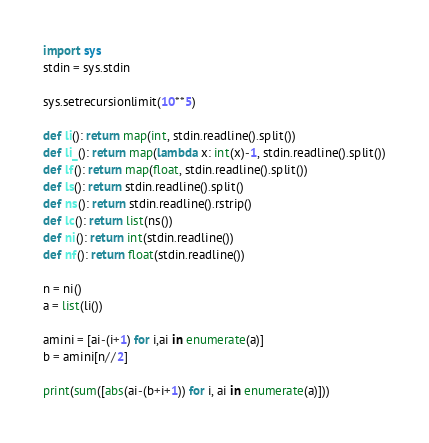Convert code to text. <code><loc_0><loc_0><loc_500><loc_500><_Python_>import sys
stdin = sys.stdin

sys.setrecursionlimit(10**5)

def li(): return map(int, stdin.readline().split())
def li_(): return map(lambda x: int(x)-1, stdin.readline().split())
def lf(): return map(float, stdin.readline().split())
def ls(): return stdin.readline().split()
def ns(): return stdin.readline().rstrip()
def lc(): return list(ns())
def ni(): return int(stdin.readline())
def nf(): return float(stdin.readline())

n = ni()
a = list(li())

amini = [ai-(i+1) for i,ai in enumerate(a)]
b = amini[n//2]

print(sum([abs(ai-(b+i+1)) for i, ai in enumerate(a)]))</code> 